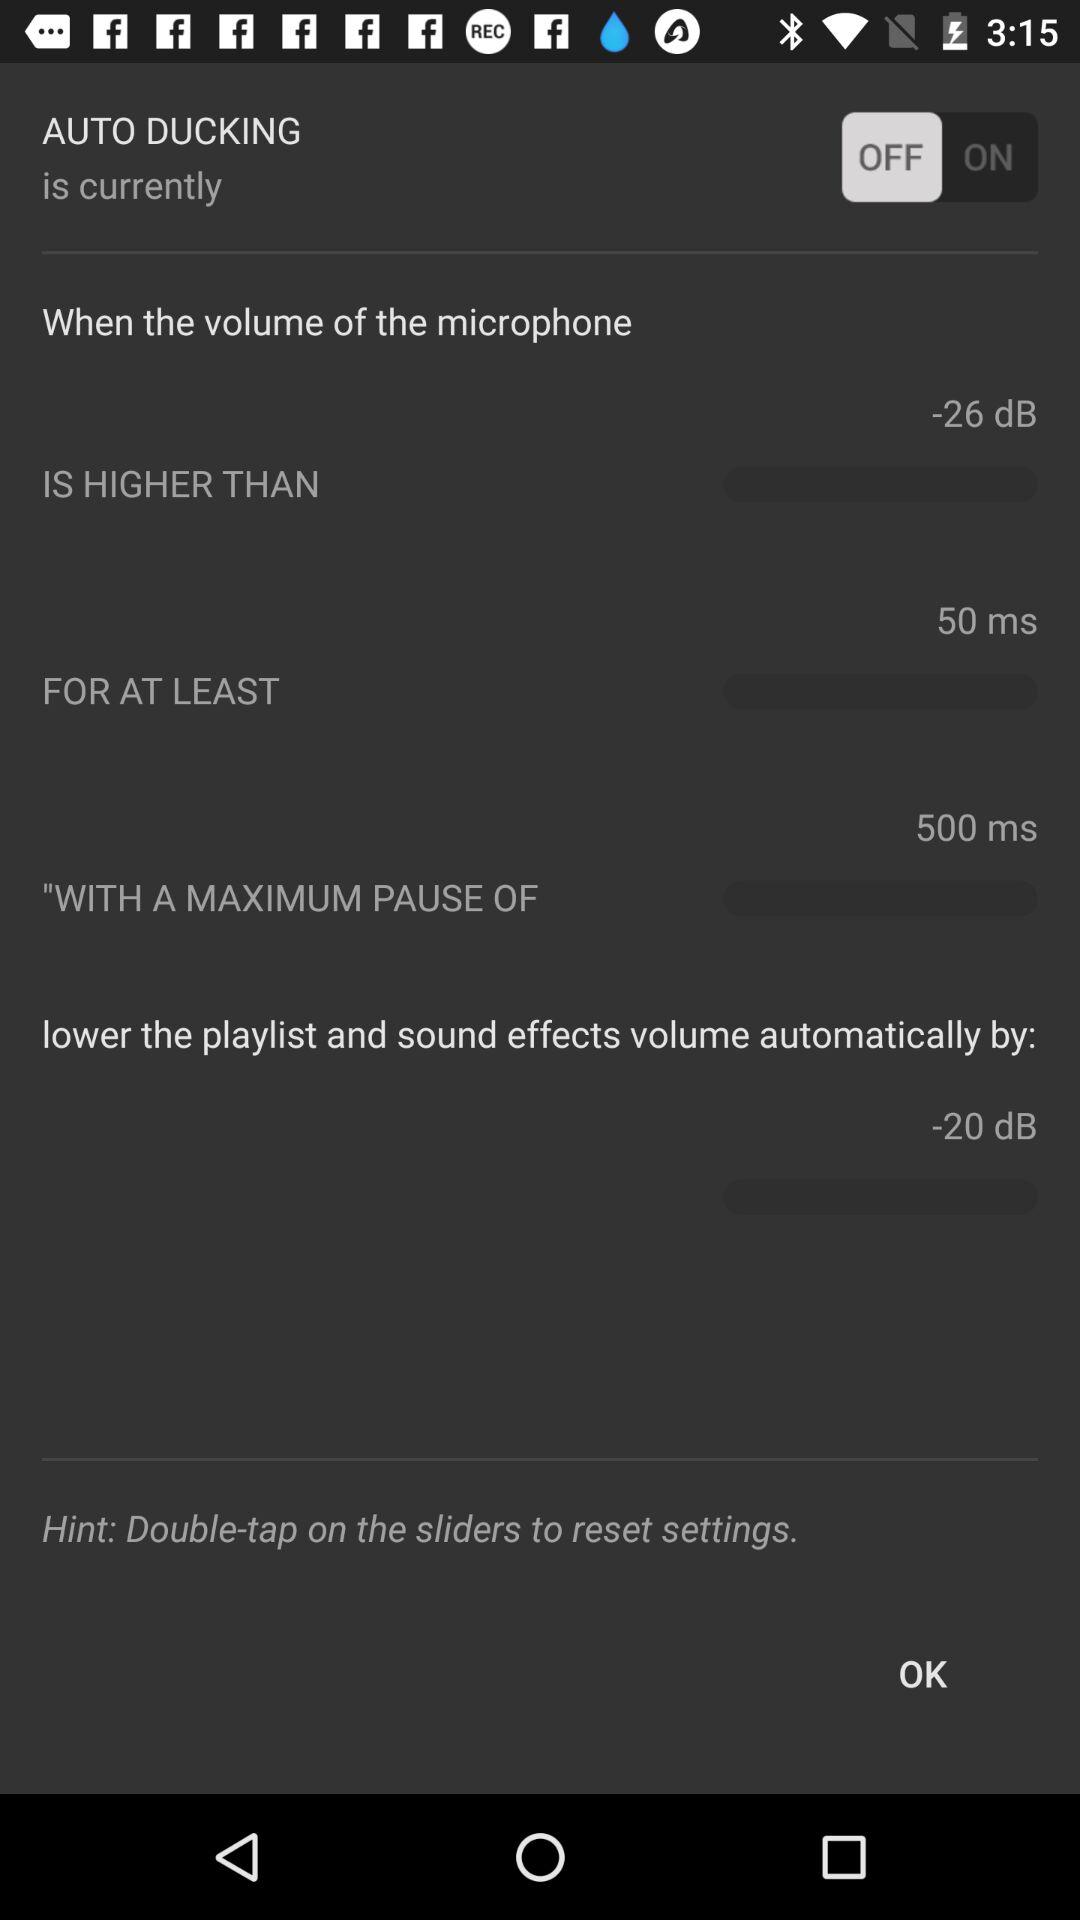What is the value of the maximum pause?
Answer the question using a single word or phrase. 500 ms 